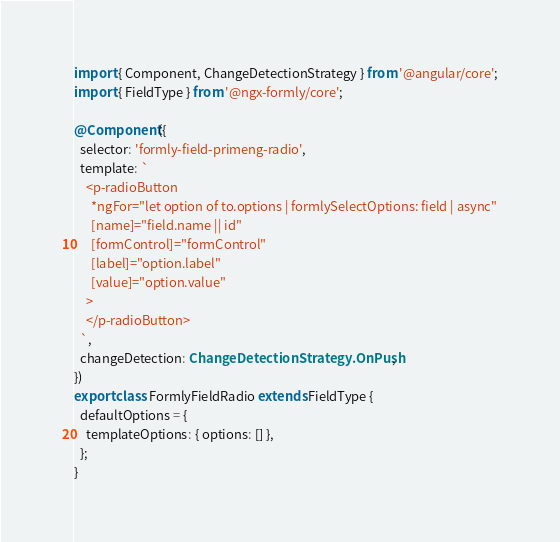Convert code to text. <code><loc_0><loc_0><loc_500><loc_500><_TypeScript_>import { Component, ChangeDetectionStrategy } from '@angular/core';
import { FieldType } from '@ngx-formly/core';

@Component({
  selector: 'formly-field-primeng-radio',
  template: `
    <p-radioButton
      *ngFor="let option of to.options | formlySelectOptions: field | async"
      [name]="field.name || id"
      [formControl]="formControl"
      [label]="option.label"
      [value]="option.value"
    >
    </p-radioButton>
  `,
  changeDetection: ChangeDetectionStrategy.OnPush,
})
export class FormlyFieldRadio extends FieldType {
  defaultOptions = {
    templateOptions: { options: [] },
  };
}
</code> 